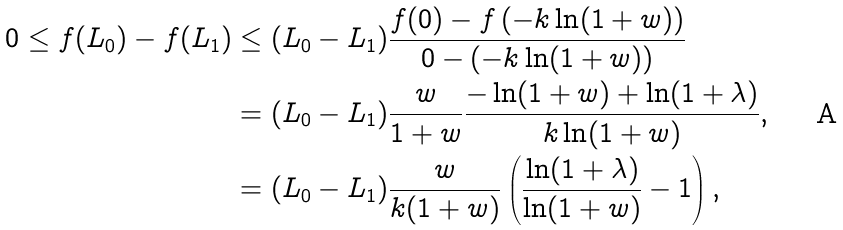<formula> <loc_0><loc_0><loc_500><loc_500>0 \leq f ( L _ { 0 } ) - f ( L _ { 1 } ) & \leq ( L _ { 0 } - L _ { 1 } ) \frac { f ( 0 ) - f \left ( - k \ln ( 1 + w ) \right ) } { 0 - ( - k \ln ( 1 + w ) ) } \\ & = ( L _ { 0 } - L _ { 1 } ) \frac { w } { 1 + w } \frac { - \ln ( 1 + w ) + \ln ( 1 + \lambda ) } { k \ln ( 1 + w ) } , \\ & = ( L _ { 0 } - L _ { 1 } ) \frac { w } { k ( 1 + w ) } \left ( \frac { \ln ( 1 + \lambda ) } { \ln ( 1 + w ) } - 1 \right ) ,</formula> 